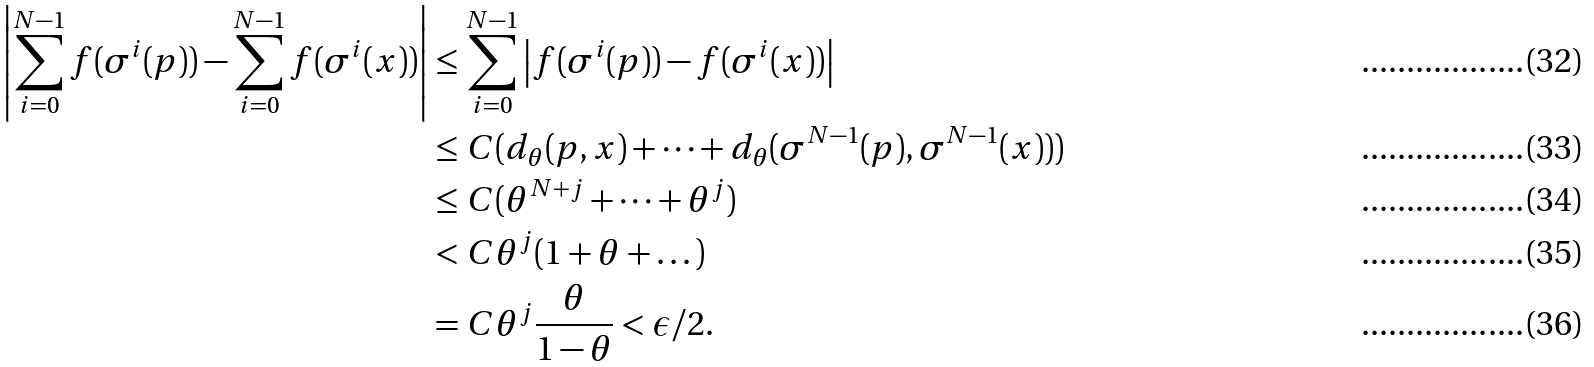Convert formula to latex. <formula><loc_0><loc_0><loc_500><loc_500>\left | \sum _ { i = 0 } ^ { N - 1 } f ( \sigma ^ { i } ( p ) ) - \sum _ { i = 0 } ^ { N - 1 } f ( \sigma ^ { i } ( x ) ) \right | & \leq \sum _ { i = 0 } ^ { N - 1 } \left | f ( \sigma ^ { i } ( p ) ) - f ( \sigma ^ { i } ( x ) ) \right | \\ & \leq C ( d _ { \theta } ( p , x ) + \dots + d _ { \theta } ( \sigma ^ { N - 1 } ( p ) , \sigma ^ { N - 1 } ( x ) ) ) \\ & \leq C ( \theta ^ { N + j } + \dots + \theta ^ { j } ) \\ & < C \theta ^ { j } ( 1 + \theta + \dots ) \\ & = C \theta ^ { j } \frac { \theta } { 1 - \theta } < \epsilon / 2 .</formula> 